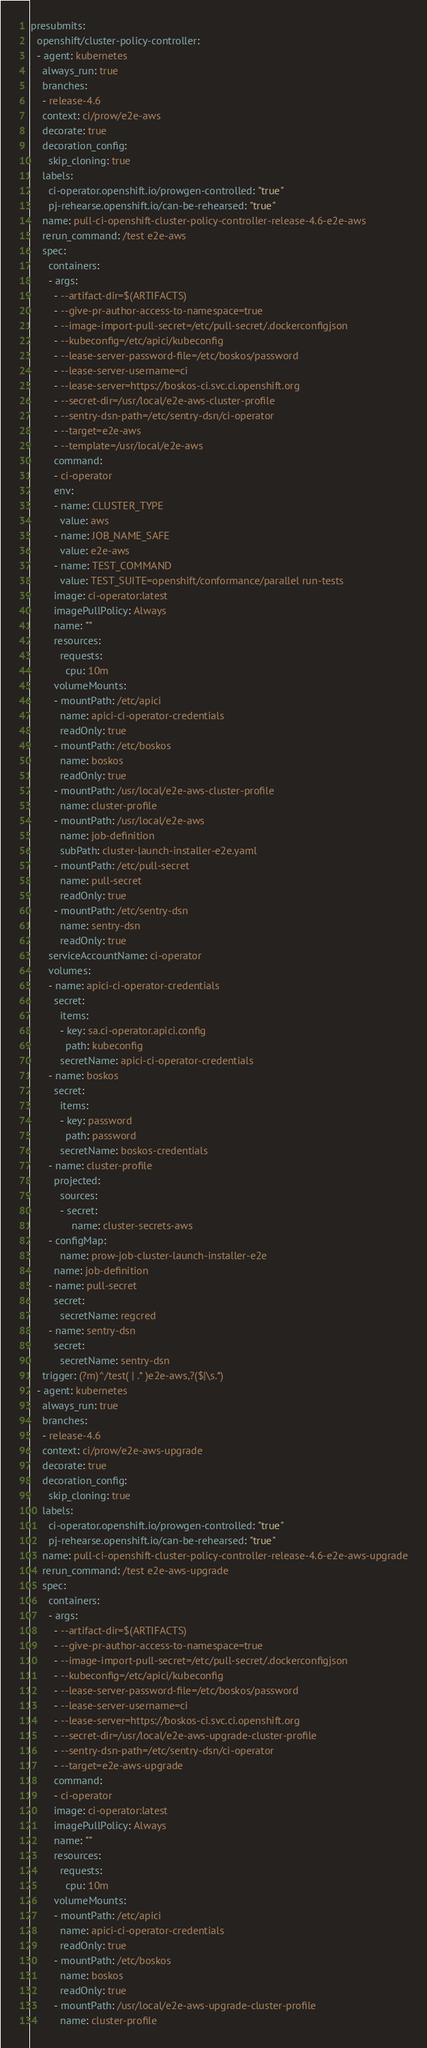<code> <loc_0><loc_0><loc_500><loc_500><_YAML_>presubmits:
  openshift/cluster-policy-controller:
  - agent: kubernetes
    always_run: true
    branches:
    - release-4.6
    context: ci/prow/e2e-aws
    decorate: true
    decoration_config:
      skip_cloning: true
    labels:
      ci-operator.openshift.io/prowgen-controlled: "true"
      pj-rehearse.openshift.io/can-be-rehearsed: "true"
    name: pull-ci-openshift-cluster-policy-controller-release-4.6-e2e-aws
    rerun_command: /test e2e-aws
    spec:
      containers:
      - args:
        - --artifact-dir=$(ARTIFACTS)
        - --give-pr-author-access-to-namespace=true
        - --image-import-pull-secret=/etc/pull-secret/.dockerconfigjson
        - --kubeconfig=/etc/apici/kubeconfig
        - --lease-server-password-file=/etc/boskos/password
        - --lease-server-username=ci
        - --lease-server=https://boskos-ci.svc.ci.openshift.org
        - --secret-dir=/usr/local/e2e-aws-cluster-profile
        - --sentry-dsn-path=/etc/sentry-dsn/ci-operator
        - --target=e2e-aws
        - --template=/usr/local/e2e-aws
        command:
        - ci-operator
        env:
        - name: CLUSTER_TYPE
          value: aws
        - name: JOB_NAME_SAFE
          value: e2e-aws
        - name: TEST_COMMAND
          value: TEST_SUITE=openshift/conformance/parallel run-tests
        image: ci-operator:latest
        imagePullPolicy: Always
        name: ""
        resources:
          requests:
            cpu: 10m
        volumeMounts:
        - mountPath: /etc/apici
          name: apici-ci-operator-credentials
          readOnly: true
        - mountPath: /etc/boskos
          name: boskos
          readOnly: true
        - mountPath: /usr/local/e2e-aws-cluster-profile
          name: cluster-profile
        - mountPath: /usr/local/e2e-aws
          name: job-definition
          subPath: cluster-launch-installer-e2e.yaml
        - mountPath: /etc/pull-secret
          name: pull-secret
          readOnly: true
        - mountPath: /etc/sentry-dsn
          name: sentry-dsn
          readOnly: true
      serviceAccountName: ci-operator
      volumes:
      - name: apici-ci-operator-credentials
        secret:
          items:
          - key: sa.ci-operator.apici.config
            path: kubeconfig
          secretName: apici-ci-operator-credentials
      - name: boskos
        secret:
          items:
          - key: password
            path: password
          secretName: boskos-credentials
      - name: cluster-profile
        projected:
          sources:
          - secret:
              name: cluster-secrets-aws
      - configMap:
          name: prow-job-cluster-launch-installer-e2e
        name: job-definition
      - name: pull-secret
        secret:
          secretName: regcred
      - name: sentry-dsn
        secret:
          secretName: sentry-dsn
    trigger: (?m)^/test( | .* )e2e-aws,?($|\s.*)
  - agent: kubernetes
    always_run: true
    branches:
    - release-4.6
    context: ci/prow/e2e-aws-upgrade
    decorate: true
    decoration_config:
      skip_cloning: true
    labels:
      ci-operator.openshift.io/prowgen-controlled: "true"
      pj-rehearse.openshift.io/can-be-rehearsed: "true"
    name: pull-ci-openshift-cluster-policy-controller-release-4.6-e2e-aws-upgrade
    rerun_command: /test e2e-aws-upgrade
    spec:
      containers:
      - args:
        - --artifact-dir=$(ARTIFACTS)
        - --give-pr-author-access-to-namespace=true
        - --image-import-pull-secret=/etc/pull-secret/.dockerconfigjson
        - --kubeconfig=/etc/apici/kubeconfig
        - --lease-server-password-file=/etc/boskos/password
        - --lease-server-username=ci
        - --lease-server=https://boskos-ci.svc.ci.openshift.org
        - --secret-dir=/usr/local/e2e-aws-upgrade-cluster-profile
        - --sentry-dsn-path=/etc/sentry-dsn/ci-operator
        - --target=e2e-aws-upgrade
        command:
        - ci-operator
        image: ci-operator:latest
        imagePullPolicy: Always
        name: ""
        resources:
          requests:
            cpu: 10m
        volumeMounts:
        - mountPath: /etc/apici
          name: apici-ci-operator-credentials
          readOnly: true
        - mountPath: /etc/boskos
          name: boskos
          readOnly: true
        - mountPath: /usr/local/e2e-aws-upgrade-cluster-profile
          name: cluster-profile</code> 